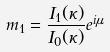<formula> <loc_0><loc_0><loc_500><loc_500>m _ { 1 } = \frac { I _ { 1 } ( \kappa ) } { I _ { 0 } ( \kappa ) } e ^ { i \mu }</formula> 